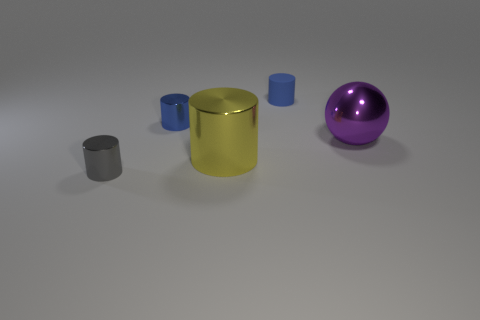There is a blue object that is made of the same material as the gray object; what size is it?
Your answer should be very brief. Small. What number of objects are tiny blue cylinders that are left of the yellow metallic thing or small objects behind the purple metallic thing?
Provide a succinct answer. 2. Is the size of the gray shiny object that is left of the purple ball the same as the tiny blue shiny object?
Your answer should be very brief. Yes. There is a big shiny object that is to the right of the small blue rubber object; what color is it?
Your answer should be compact. Purple. What is the color of the small rubber thing that is the same shape as the large yellow object?
Your response must be concise. Blue. There is a small blue cylinder on the right side of the tiny metal object behind the small gray metallic thing; how many objects are behind it?
Offer a very short reply. 0. Is the number of blue metal cylinders that are in front of the yellow shiny object less than the number of yellow cylinders?
Give a very brief answer. Yes. What is the size of the yellow shiny thing that is the same shape as the blue metallic object?
Ensure brevity in your answer.  Large. What number of tiny gray objects are the same material as the big yellow cylinder?
Give a very brief answer. 1. Are the small blue object left of the large yellow metallic cylinder and the yellow object made of the same material?
Provide a short and direct response. Yes. 